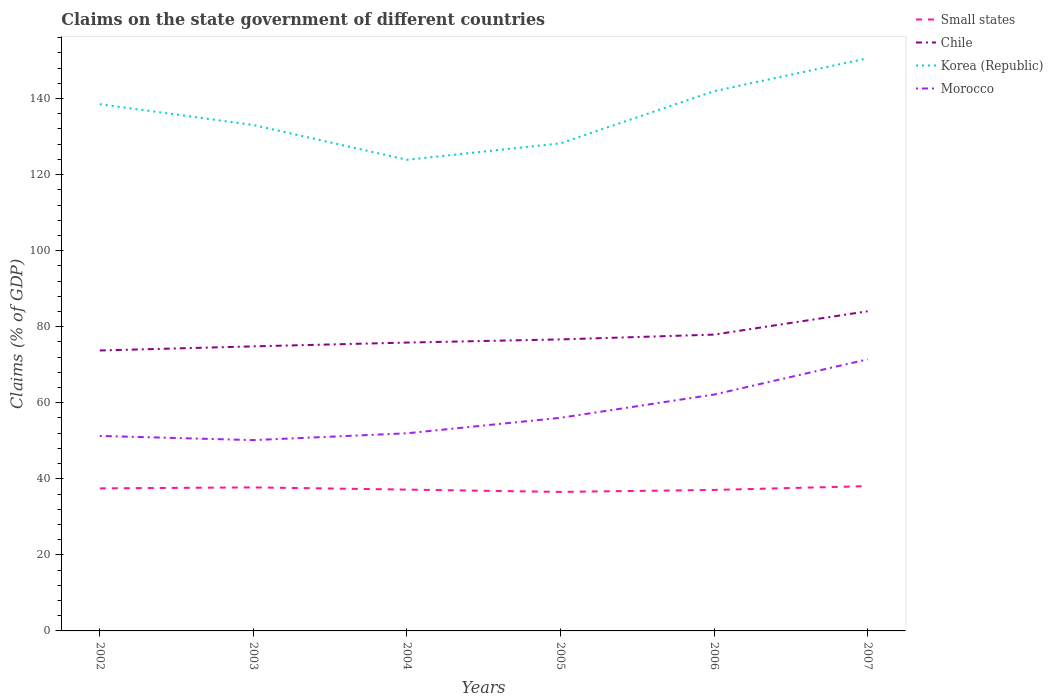How many different coloured lines are there?
Provide a succinct answer. 4. Is the number of lines equal to the number of legend labels?
Keep it short and to the point. Yes. Across all years, what is the maximum percentage of GDP claimed on the state government in Small states?
Provide a succinct answer. 36.56. What is the total percentage of GDP claimed on the state government in Korea (Republic) in the graph?
Your answer should be very brief. -22.38. What is the difference between the highest and the second highest percentage of GDP claimed on the state government in Morocco?
Provide a succinct answer. 21.24. Is the percentage of GDP claimed on the state government in Korea (Republic) strictly greater than the percentage of GDP claimed on the state government in Morocco over the years?
Offer a very short reply. No. How many years are there in the graph?
Your response must be concise. 6. What is the difference between two consecutive major ticks on the Y-axis?
Provide a succinct answer. 20. Does the graph contain grids?
Your answer should be very brief. No. What is the title of the graph?
Provide a succinct answer. Claims on the state government of different countries. Does "Luxembourg" appear as one of the legend labels in the graph?
Make the answer very short. No. What is the label or title of the Y-axis?
Make the answer very short. Claims (% of GDP). What is the Claims (% of GDP) in Small states in 2002?
Your response must be concise. 37.49. What is the Claims (% of GDP) of Chile in 2002?
Provide a short and direct response. 73.75. What is the Claims (% of GDP) in Korea (Republic) in 2002?
Ensure brevity in your answer.  138.52. What is the Claims (% of GDP) in Morocco in 2002?
Ensure brevity in your answer.  51.28. What is the Claims (% of GDP) of Small states in 2003?
Offer a terse response. 37.74. What is the Claims (% of GDP) in Chile in 2003?
Make the answer very short. 74.83. What is the Claims (% of GDP) in Korea (Republic) in 2003?
Your answer should be very brief. 133.05. What is the Claims (% of GDP) in Morocco in 2003?
Your response must be concise. 50.18. What is the Claims (% of GDP) in Small states in 2004?
Offer a terse response. 37.17. What is the Claims (% of GDP) of Chile in 2004?
Provide a short and direct response. 75.83. What is the Claims (% of GDP) in Korea (Republic) in 2004?
Your response must be concise. 123.89. What is the Claims (% of GDP) of Morocco in 2004?
Make the answer very short. 51.97. What is the Claims (% of GDP) of Small states in 2005?
Make the answer very short. 36.56. What is the Claims (% of GDP) in Chile in 2005?
Offer a very short reply. 76.66. What is the Claims (% of GDP) in Korea (Republic) in 2005?
Your response must be concise. 128.22. What is the Claims (% of GDP) in Morocco in 2005?
Make the answer very short. 56.05. What is the Claims (% of GDP) of Small states in 2006?
Provide a succinct answer. 37.08. What is the Claims (% of GDP) of Chile in 2006?
Give a very brief answer. 77.92. What is the Claims (% of GDP) in Korea (Republic) in 2006?
Offer a very short reply. 141.94. What is the Claims (% of GDP) in Morocco in 2006?
Give a very brief answer. 62.16. What is the Claims (% of GDP) of Small states in 2007?
Your response must be concise. 38.07. What is the Claims (% of GDP) of Chile in 2007?
Your response must be concise. 84.06. What is the Claims (% of GDP) in Korea (Republic) in 2007?
Offer a very short reply. 150.6. What is the Claims (% of GDP) of Morocco in 2007?
Offer a terse response. 71.41. Across all years, what is the maximum Claims (% of GDP) of Small states?
Give a very brief answer. 38.07. Across all years, what is the maximum Claims (% of GDP) of Chile?
Provide a short and direct response. 84.06. Across all years, what is the maximum Claims (% of GDP) in Korea (Republic)?
Keep it short and to the point. 150.6. Across all years, what is the maximum Claims (% of GDP) of Morocco?
Provide a short and direct response. 71.41. Across all years, what is the minimum Claims (% of GDP) in Small states?
Your answer should be very brief. 36.56. Across all years, what is the minimum Claims (% of GDP) of Chile?
Provide a succinct answer. 73.75. Across all years, what is the minimum Claims (% of GDP) in Korea (Republic)?
Provide a succinct answer. 123.89. Across all years, what is the minimum Claims (% of GDP) in Morocco?
Provide a succinct answer. 50.18. What is the total Claims (% of GDP) in Small states in the graph?
Your answer should be very brief. 224.1. What is the total Claims (% of GDP) of Chile in the graph?
Keep it short and to the point. 463.06. What is the total Claims (% of GDP) in Korea (Republic) in the graph?
Provide a succinct answer. 816.23. What is the total Claims (% of GDP) of Morocco in the graph?
Provide a short and direct response. 343.05. What is the difference between the Claims (% of GDP) in Small states in 2002 and that in 2003?
Make the answer very short. -0.25. What is the difference between the Claims (% of GDP) of Chile in 2002 and that in 2003?
Provide a short and direct response. -1.08. What is the difference between the Claims (% of GDP) in Korea (Republic) in 2002 and that in 2003?
Offer a very short reply. 5.47. What is the difference between the Claims (% of GDP) of Morocco in 2002 and that in 2003?
Your answer should be compact. 1.1. What is the difference between the Claims (% of GDP) of Small states in 2002 and that in 2004?
Your answer should be very brief. 0.32. What is the difference between the Claims (% of GDP) in Chile in 2002 and that in 2004?
Your answer should be compact. -2.08. What is the difference between the Claims (% of GDP) of Korea (Republic) in 2002 and that in 2004?
Provide a short and direct response. 14.62. What is the difference between the Claims (% of GDP) in Morocco in 2002 and that in 2004?
Your answer should be compact. -0.69. What is the difference between the Claims (% of GDP) in Small states in 2002 and that in 2005?
Give a very brief answer. 0.93. What is the difference between the Claims (% of GDP) in Chile in 2002 and that in 2005?
Your response must be concise. -2.91. What is the difference between the Claims (% of GDP) in Korea (Republic) in 2002 and that in 2005?
Your answer should be compact. 10.3. What is the difference between the Claims (% of GDP) in Morocco in 2002 and that in 2005?
Ensure brevity in your answer.  -4.77. What is the difference between the Claims (% of GDP) of Small states in 2002 and that in 2006?
Your response must be concise. 0.41. What is the difference between the Claims (% of GDP) of Chile in 2002 and that in 2006?
Make the answer very short. -4.17. What is the difference between the Claims (% of GDP) of Korea (Republic) in 2002 and that in 2006?
Your answer should be very brief. -3.42. What is the difference between the Claims (% of GDP) in Morocco in 2002 and that in 2006?
Your answer should be very brief. -10.87. What is the difference between the Claims (% of GDP) of Small states in 2002 and that in 2007?
Make the answer very short. -0.59. What is the difference between the Claims (% of GDP) of Chile in 2002 and that in 2007?
Your answer should be very brief. -10.31. What is the difference between the Claims (% of GDP) of Korea (Republic) in 2002 and that in 2007?
Keep it short and to the point. -12.08. What is the difference between the Claims (% of GDP) in Morocco in 2002 and that in 2007?
Offer a terse response. -20.13. What is the difference between the Claims (% of GDP) in Small states in 2003 and that in 2004?
Give a very brief answer. 0.58. What is the difference between the Claims (% of GDP) of Chile in 2003 and that in 2004?
Offer a very short reply. -1. What is the difference between the Claims (% of GDP) in Korea (Republic) in 2003 and that in 2004?
Your answer should be very brief. 9.15. What is the difference between the Claims (% of GDP) of Morocco in 2003 and that in 2004?
Keep it short and to the point. -1.79. What is the difference between the Claims (% of GDP) of Small states in 2003 and that in 2005?
Your answer should be compact. 1.18. What is the difference between the Claims (% of GDP) of Chile in 2003 and that in 2005?
Keep it short and to the point. -1.83. What is the difference between the Claims (% of GDP) in Korea (Republic) in 2003 and that in 2005?
Make the answer very short. 4.82. What is the difference between the Claims (% of GDP) of Morocco in 2003 and that in 2005?
Offer a terse response. -5.87. What is the difference between the Claims (% of GDP) in Small states in 2003 and that in 2006?
Offer a terse response. 0.66. What is the difference between the Claims (% of GDP) of Chile in 2003 and that in 2006?
Give a very brief answer. -3.09. What is the difference between the Claims (% of GDP) of Korea (Republic) in 2003 and that in 2006?
Your answer should be compact. -8.89. What is the difference between the Claims (% of GDP) in Morocco in 2003 and that in 2006?
Your answer should be very brief. -11.98. What is the difference between the Claims (% of GDP) of Chile in 2003 and that in 2007?
Keep it short and to the point. -9.23. What is the difference between the Claims (% of GDP) of Korea (Republic) in 2003 and that in 2007?
Your response must be concise. -17.55. What is the difference between the Claims (% of GDP) of Morocco in 2003 and that in 2007?
Provide a short and direct response. -21.24. What is the difference between the Claims (% of GDP) in Small states in 2004 and that in 2005?
Give a very brief answer. 0.61. What is the difference between the Claims (% of GDP) in Chile in 2004 and that in 2005?
Your answer should be very brief. -0.83. What is the difference between the Claims (% of GDP) of Korea (Republic) in 2004 and that in 2005?
Your answer should be very brief. -4.33. What is the difference between the Claims (% of GDP) in Morocco in 2004 and that in 2005?
Your answer should be very brief. -4.08. What is the difference between the Claims (% of GDP) of Small states in 2004 and that in 2006?
Make the answer very short. 0.08. What is the difference between the Claims (% of GDP) of Chile in 2004 and that in 2006?
Ensure brevity in your answer.  -2.09. What is the difference between the Claims (% of GDP) of Korea (Republic) in 2004 and that in 2006?
Provide a short and direct response. -18.05. What is the difference between the Claims (% of GDP) in Morocco in 2004 and that in 2006?
Offer a very short reply. -10.19. What is the difference between the Claims (% of GDP) in Small states in 2004 and that in 2007?
Provide a short and direct response. -0.91. What is the difference between the Claims (% of GDP) in Chile in 2004 and that in 2007?
Your answer should be compact. -8.23. What is the difference between the Claims (% of GDP) in Korea (Republic) in 2004 and that in 2007?
Provide a succinct answer. -26.71. What is the difference between the Claims (% of GDP) in Morocco in 2004 and that in 2007?
Your response must be concise. -19.44. What is the difference between the Claims (% of GDP) of Small states in 2005 and that in 2006?
Offer a very short reply. -0.53. What is the difference between the Claims (% of GDP) of Chile in 2005 and that in 2006?
Your response must be concise. -1.26. What is the difference between the Claims (% of GDP) of Korea (Republic) in 2005 and that in 2006?
Give a very brief answer. -13.72. What is the difference between the Claims (% of GDP) in Morocco in 2005 and that in 2006?
Provide a short and direct response. -6.11. What is the difference between the Claims (% of GDP) of Small states in 2005 and that in 2007?
Ensure brevity in your answer.  -1.52. What is the difference between the Claims (% of GDP) in Chile in 2005 and that in 2007?
Provide a succinct answer. -7.4. What is the difference between the Claims (% of GDP) of Korea (Republic) in 2005 and that in 2007?
Your answer should be compact. -22.38. What is the difference between the Claims (% of GDP) of Morocco in 2005 and that in 2007?
Offer a terse response. -15.36. What is the difference between the Claims (% of GDP) of Small states in 2006 and that in 2007?
Provide a succinct answer. -0.99. What is the difference between the Claims (% of GDP) in Chile in 2006 and that in 2007?
Make the answer very short. -6.14. What is the difference between the Claims (% of GDP) in Korea (Republic) in 2006 and that in 2007?
Ensure brevity in your answer.  -8.66. What is the difference between the Claims (% of GDP) in Morocco in 2006 and that in 2007?
Ensure brevity in your answer.  -9.26. What is the difference between the Claims (% of GDP) in Small states in 2002 and the Claims (% of GDP) in Chile in 2003?
Give a very brief answer. -37.35. What is the difference between the Claims (% of GDP) of Small states in 2002 and the Claims (% of GDP) of Korea (Republic) in 2003?
Ensure brevity in your answer.  -95.56. What is the difference between the Claims (% of GDP) in Small states in 2002 and the Claims (% of GDP) in Morocco in 2003?
Provide a succinct answer. -12.69. What is the difference between the Claims (% of GDP) in Chile in 2002 and the Claims (% of GDP) in Korea (Republic) in 2003?
Offer a very short reply. -59.3. What is the difference between the Claims (% of GDP) in Chile in 2002 and the Claims (% of GDP) in Morocco in 2003?
Your answer should be compact. 23.57. What is the difference between the Claims (% of GDP) of Korea (Republic) in 2002 and the Claims (% of GDP) of Morocco in 2003?
Give a very brief answer. 88.34. What is the difference between the Claims (% of GDP) in Small states in 2002 and the Claims (% of GDP) in Chile in 2004?
Your response must be concise. -38.34. What is the difference between the Claims (% of GDP) of Small states in 2002 and the Claims (% of GDP) of Korea (Republic) in 2004?
Offer a very short reply. -86.41. What is the difference between the Claims (% of GDP) of Small states in 2002 and the Claims (% of GDP) of Morocco in 2004?
Your answer should be very brief. -14.48. What is the difference between the Claims (% of GDP) in Chile in 2002 and the Claims (% of GDP) in Korea (Republic) in 2004?
Provide a succinct answer. -50.14. What is the difference between the Claims (% of GDP) in Chile in 2002 and the Claims (% of GDP) in Morocco in 2004?
Keep it short and to the point. 21.78. What is the difference between the Claims (% of GDP) in Korea (Republic) in 2002 and the Claims (% of GDP) in Morocco in 2004?
Your answer should be compact. 86.55. What is the difference between the Claims (% of GDP) of Small states in 2002 and the Claims (% of GDP) of Chile in 2005?
Ensure brevity in your answer.  -39.17. What is the difference between the Claims (% of GDP) of Small states in 2002 and the Claims (% of GDP) of Korea (Republic) in 2005?
Ensure brevity in your answer.  -90.74. What is the difference between the Claims (% of GDP) in Small states in 2002 and the Claims (% of GDP) in Morocco in 2005?
Give a very brief answer. -18.56. What is the difference between the Claims (% of GDP) of Chile in 2002 and the Claims (% of GDP) of Korea (Republic) in 2005?
Your response must be concise. -54.47. What is the difference between the Claims (% of GDP) in Chile in 2002 and the Claims (% of GDP) in Morocco in 2005?
Your answer should be very brief. 17.7. What is the difference between the Claims (% of GDP) in Korea (Republic) in 2002 and the Claims (% of GDP) in Morocco in 2005?
Make the answer very short. 82.47. What is the difference between the Claims (% of GDP) in Small states in 2002 and the Claims (% of GDP) in Chile in 2006?
Your answer should be compact. -40.44. What is the difference between the Claims (% of GDP) in Small states in 2002 and the Claims (% of GDP) in Korea (Republic) in 2006?
Your response must be concise. -104.45. What is the difference between the Claims (% of GDP) in Small states in 2002 and the Claims (% of GDP) in Morocco in 2006?
Give a very brief answer. -24.67. What is the difference between the Claims (% of GDP) of Chile in 2002 and the Claims (% of GDP) of Korea (Republic) in 2006?
Ensure brevity in your answer.  -68.19. What is the difference between the Claims (% of GDP) in Chile in 2002 and the Claims (% of GDP) in Morocco in 2006?
Make the answer very short. 11.59. What is the difference between the Claims (% of GDP) of Korea (Republic) in 2002 and the Claims (% of GDP) of Morocco in 2006?
Provide a short and direct response. 76.36. What is the difference between the Claims (% of GDP) of Small states in 2002 and the Claims (% of GDP) of Chile in 2007?
Provide a short and direct response. -46.57. What is the difference between the Claims (% of GDP) of Small states in 2002 and the Claims (% of GDP) of Korea (Republic) in 2007?
Provide a succinct answer. -113.11. What is the difference between the Claims (% of GDP) in Small states in 2002 and the Claims (% of GDP) in Morocco in 2007?
Give a very brief answer. -33.93. What is the difference between the Claims (% of GDP) in Chile in 2002 and the Claims (% of GDP) in Korea (Republic) in 2007?
Provide a short and direct response. -76.85. What is the difference between the Claims (% of GDP) of Chile in 2002 and the Claims (% of GDP) of Morocco in 2007?
Keep it short and to the point. 2.34. What is the difference between the Claims (% of GDP) of Korea (Republic) in 2002 and the Claims (% of GDP) of Morocco in 2007?
Provide a short and direct response. 67.11. What is the difference between the Claims (% of GDP) in Small states in 2003 and the Claims (% of GDP) in Chile in 2004?
Provide a short and direct response. -38.09. What is the difference between the Claims (% of GDP) of Small states in 2003 and the Claims (% of GDP) of Korea (Republic) in 2004?
Your answer should be very brief. -86.15. What is the difference between the Claims (% of GDP) of Small states in 2003 and the Claims (% of GDP) of Morocco in 2004?
Your answer should be compact. -14.23. What is the difference between the Claims (% of GDP) in Chile in 2003 and the Claims (% of GDP) in Korea (Republic) in 2004?
Your answer should be compact. -49.06. What is the difference between the Claims (% of GDP) in Chile in 2003 and the Claims (% of GDP) in Morocco in 2004?
Make the answer very short. 22.86. What is the difference between the Claims (% of GDP) in Korea (Republic) in 2003 and the Claims (% of GDP) in Morocco in 2004?
Your answer should be very brief. 81.08. What is the difference between the Claims (% of GDP) of Small states in 2003 and the Claims (% of GDP) of Chile in 2005?
Make the answer very short. -38.92. What is the difference between the Claims (% of GDP) of Small states in 2003 and the Claims (% of GDP) of Korea (Republic) in 2005?
Provide a succinct answer. -90.48. What is the difference between the Claims (% of GDP) in Small states in 2003 and the Claims (% of GDP) in Morocco in 2005?
Provide a short and direct response. -18.31. What is the difference between the Claims (% of GDP) in Chile in 2003 and the Claims (% of GDP) in Korea (Republic) in 2005?
Ensure brevity in your answer.  -53.39. What is the difference between the Claims (% of GDP) of Chile in 2003 and the Claims (% of GDP) of Morocco in 2005?
Keep it short and to the point. 18.78. What is the difference between the Claims (% of GDP) in Korea (Republic) in 2003 and the Claims (% of GDP) in Morocco in 2005?
Offer a very short reply. 77. What is the difference between the Claims (% of GDP) in Small states in 2003 and the Claims (% of GDP) in Chile in 2006?
Your answer should be compact. -40.18. What is the difference between the Claims (% of GDP) in Small states in 2003 and the Claims (% of GDP) in Korea (Republic) in 2006?
Your answer should be compact. -104.2. What is the difference between the Claims (% of GDP) of Small states in 2003 and the Claims (% of GDP) of Morocco in 2006?
Provide a succinct answer. -24.42. What is the difference between the Claims (% of GDP) of Chile in 2003 and the Claims (% of GDP) of Korea (Republic) in 2006?
Provide a succinct answer. -67.11. What is the difference between the Claims (% of GDP) in Chile in 2003 and the Claims (% of GDP) in Morocco in 2006?
Your response must be concise. 12.68. What is the difference between the Claims (% of GDP) in Korea (Republic) in 2003 and the Claims (% of GDP) in Morocco in 2006?
Make the answer very short. 70.89. What is the difference between the Claims (% of GDP) of Small states in 2003 and the Claims (% of GDP) of Chile in 2007?
Your response must be concise. -46.32. What is the difference between the Claims (% of GDP) in Small states in 2003 and the Claims (% of GDP) in Korea (Republic) in 2007?
Your answer should be compact. -112.86. What is the difference between the Claims (% of GDP) of Small states in 2003 and the Claims (% of GDP) of Morocco in 2007?
Your response must be concise. -33.67. What is the difference between the Claims (% of GDP) of Chile in 2003 and the Claims (% of GDP) of Korea (Republic) in 2007?
Keep it short and to the point. -75.77. What is the difference between the Claims (% of GDP) in Chile in 2003 and the Claims (% of GDP) in Morocco in 2007?
Offer a very short reply. 3.42. What is the difference between the Claims (% of GDP) of Korea (Republic) in 2003 and the Claims (% of GDP) of Morocco in 2007?
Provide a succinct answer. 61.64. What is the difference between the Claims (% of GDP) in Small states in 2004 and the Claims (% of GDP) in Chile in 2005?
Ensure brevity in your answer.  -39.5. What is the difference between the Claims (% of GDP) of Small states in 2004 and the Claims (% of GDP) of Korea (Republic) in 2005?
Provide a succinct answer. -91.06. What is the difference between the Claims (% of GDP) in Small states in 2004 and the Claims (% of GDP) in Morocco in 2005?
Offer a terse response. -18.88. What is the difference between the Claims (% of GDP) in Chile in 2004 and the Claims (% of GDP) in Korea (Republic) in 2005?
Make the answer very short. -52.39. What is the difference between the Claims (% of GDP) in Chile in 2004 and the Claims (% of GDP) in Morocco in 2005?
Give a very brief answer. 19.78. What is the difference between the Claims (% of GDP) of Korea (Republic) in 2004 and the Claims (% of GDP) of Morocco in 2005?
Provide a short and direct response. 67.85. What is the difference between the Claims (% of GDP) in Small states in 2004 and the Claims (% of GDP) in Chile in 2006?
Keep it short and to the point. -40.76. What is the difference between the Claims (% of GDP) in Small states in 2004 and the Claims (% of GDP) in Korea (Republic) in 2006?
Give a very brief answer. -104.78. What is the difference between the Claims (% of GDP) in Small states in 2004 and the Claims (% of GDP) in Morocco in 2006?
Provide a short and direct response. -24.99. What is the difference between the Claims (% of GDP) in Chile in 2004 and the Claims (% of GDP) in Korea (Republic) in 2006?
Offer a terse response. -66.11. What is the difference between the Claims (% of GDP) in Chile in 2004 and the Claims (% of GDP) in Morocco in 2006?
Give a very brief answer. 13.68. What is the difference between the Claims (% of GDP) in Korea (Republic) in 2004 and the Claims (% of GDP) in Morocco in 2006?
Provide a succinct answer. 61.74. What is the difference between the Claims (% of GDP) of Small states in 2004 and the Claims (% of GDP) of Chile in 2007?
Offer a very short reply. -46.9. What is the difference between the Claims (% of GDP) in Small states in 2004 and the Claims (% of GDP) in Korea (Republic) in 2007?
Give a very brief answer. -113.43. What is the difference between the Claims (% of GDP) of Small states in 2004 and the Claims (% of GDP) of Morocco in 2007?
Provide a succinct answer. -34.25. What is the difference between the Claims (% of GDP) of Chile in 2004 and the Claims (% of GDP) of Korea (Republic) in 2007?
Make the answer very short. -74.77. What is the difference between the Claims (% of GDP) in Chile in 2004 and the Claims (% of GDP) in Morocco in 2007?
Ensure brevity in your answer.  4.42. What is the difference between the Claims (% of GDP) of Korea (Republic) in 2004 and the Claims (% of GDP) of Morocco in 2007?
Provide a short and direct response. 52.48. What is the difference between the Claims (% of GDP) in Small states in 2005 and the Claims (% of GDP) in Chile in 2006?
Offer a very short reply. -41.37. What is the difference between the Claims (% of GDP) in Small states in 2005 and the Claims (% of GDP) in Korea (Republic) in 2006?
Make the answer very short. -105.38. What is the difference between the Claims (% of GDP) in Small states in 2005 and the Claims (% of GDP) in Morocco in 2006?
Offer a very short reply. -25.6. What is the difference between the Claims (% of GDP) in Chile in 2005 and the Claims (% of GDP) in Korea (Republic) in 2006?
Offer a terse response. -65.28. What is the difference between the Claims (% of GDP) in Chile in 2005 and the Claims (% of GDP) in Morocco in 2006?
Ensure brevity in your answer.  14.51. What is the difference between the Claims (% of GDP) in Korea (Republic) in 2005 and the Claims (% of GDP) in Morocco in 2006?
Ensure brevity in your answer.  66.07. What is the difference between the Claims (% of GDP) in Small states in 2005 and the Claims (% of GDP) in Chile in 2007?
Make the answer very short. -47.5. What is the difference between the Claims (% of GDP) of Small states in 2005 and the Claims (% of GDP) of Korea (Republic) in 2007?
Offer a terse response. -114.04. What is the difference between the Claims (% of GDP) in Small states in 2005 and the Claims (% of GDP) in Morocco in 2007?
Your response must be concise. -34.86. What is the difference between the Claims (% of GDP) in Chile in 2005 and the Claims (% of GDP) in Korea (Republic) in 2007?
Give a very brief answer. -73.94. What is the difference between the Claims (% of GDP) in Chile in 2005 and the Claims (% of GDP) in Morocco in 2007?
Offer a very short reply. 5.25. What is the difference between the Claims (% of GDP) of Korea (Republic) in 2005 and the Claims (% of GDP) of Morocco in 2007?
Give a very brief answer. 56.81. What is the difference between the Claims (% of GDP) of Small states in 2006 and the Claims (% of GDP) of Chile in 2007?
Offer a very short reply. -46.98. What is the difference between the Claims (% of GDP) in Small states in 2006 and the Claims (% of GDP) in Korea (Republic) in 2007?
Give a very brief answer. -113.52. What is the difference between the Claims (% of GDP) of Small states in 2006 and the Claims (% of GDP) of Morocco in 2007?
Your answer should be very brief. -34.33. What is the difference between the Claims (% of GDP) in Chile in 2006 and the Claims (% of GDP) in Korea (Republic) in 2007?
Provide a succinct answer. -72.68. What is the difference between the Claims (% of GDP) in Chile in 2006 and the Claims (% of GDP) in Morocco in 2007?
Keep it short and to the point. 6.51. What is the difference between the Claims (% of GDP) in Korea (Republic) in 2006 and the Claims (% of GDP) in Morocco in 2007?
Your response must be concise. 70.53. What is the average Claims (% of GDP) in Small states per year?
Your response must be concise. 37.35. What is the average Claims (% of GDP) in Chile per year?
Your answer should be compact. 77.18. What is the average Claims (% of GDP) of Korea (Republic) per year?
Offer a very short reply. 136.04. What is the average Claims (% of GDP) in Morocco per year?
Offer a very short reply. 57.17. In the year 2002, what is the difference between the Claims (% of GDP) of Small states and Claims (% of GDP) of Chile?
Keep it short and to the point. -36.26. In the year 2002, what is the difference between the Claims (% of GDP) of Small states and Claims (% of GDP) of Korea (Republic)?
Offer a terse response. -101.03. In the year 2002, what is the difference between the Claims (% of GDP) in Small states and Claims (% of GDP) in Morocco?
Keep it short and to the point. -13.79. In the year 2002, what is the difference between the Claims (% of GDP) in Chile and Claims (% of GDP) in Korea (Republic)?
Offer a very short reply. -64.77. In the year 2002, what is the difference between the Claims (% of GDP) of Chile and Claims (% of GDP) of Morocco?
Provide a short and direct response. 22.47. In the year 2002, what is the difference between the Claims (% of GDP) of Korea (Republic) and Claims (% of GDP) of Morocco?
Your answer should be compact. 87.24. In the year 2003, what is the difference between the Claims (% of GDP) of Small states and Claims (% of GDP) of Chile?
Offer a terse response. -37.09. In the year 2003, what is the difference between the Claims (% of GDP) in Small states and Claims (% of GDP) in Korea (Republic)?
Ensure brevity in your answer.  -95.31. In the year 2003, what is the difference between the Claims (% of GDP) of Small states and Claims (% of GDP) of Morocco?
Provide a succinct answer. -12.44. In the year 2003, what is the difference between the Claims (% of GDP) in Chile and Claims (% of GDP) in Korea (Republic)?
Make the answer very short. -58.22. In the year 2003, what is the difference between the Claims (% of GDP) of Chile and Claims (% of GDP) of Morocco?
Give a very brief answer. 24.66. In the year 2003, what is the difference between the Claims (% of GDP) in Korea (Republic) and Claims (% of GDP) in Morocco?
Provide a succinct answer. 82.87. In the year 2004, what is the difference between the Claims (% of GDP) in Small states and Claims (% of GDP) in Chile?
Your answer should be compact. -38.67. In the year 2004, what is the difference between the Claims (% of GDP) in Small states and Claims (% of GDP) in Korea (Republic)?
Offer a very short reply. -86.73. In the year 2004, what is the difference between the Claims (% of GDP) in Small states and Claims (% of GDP) in Morocco?
Give a very brief answer. -14.81. In the year 2004, what is the difference between the Claims (% of GDP) of Chile and Claims (% of GDP) of Korea (Republic)?
Provide a short and direct response. -48.06. In the year 2004, what is the difference between the Claims (% of GDP) of Chile and Claims (% of GDP) of Morocco?
Keep it short and to the point. 23.86. In the year 2004, what is the difference between the Claims (% of GDP) of Korea (Republic) and Claims (% of GDP) of Morocco?
Provide a short and direct response. 71.92. In the year 2005, what is the difference between the Claims (% of GDP) of Small states and Claims (% of GDP) of Chile?
Offer a terse response. -40.11. In the year 2005, what is the difference between the Claims (% of GDP) of Small states and Claims (% of GDP) of Korea (Republic)?
Ensure brevity in your answer.  -91.67. In the year 2005, what is the difference between the Claims (% of GDP) of Small states and Claims (% of GDP) of Morocco?
Provide a succinct answer. -19.49. In the year 2005, what is the difference between the Claims (% of GDP) of Chile and Claims (% of GDP) of Korea (Republic)?
Keep it short and to the point. -51.56. In the year 2005, what is the difference between the Claims (% of GDP) in Chile and Claims (% of GDP) in Morocco?
Your answer should be compact. 20.61. In the year 2005, what is the difference between the Claims (% of GDP) in Korea (Republic) and Claims (% of GDP) in Morocco?
Make the answer very short. 72.18. In the year 2006, what is the difference between the Claims (% of GDP) in Small states and Claims (% of GDP) in Chile?
Your answer should be very brief. -40.84. In the year 2006, what is the difference between the Claims (% of GDP) of Small states and Claims (% of GDP) of Korea (Republic)?
Give a very brief answer. -104.86. In the year 2006, what is the difference between the Claims (% of GDP) of Small states and Claims (% of GDP) of Morocco?
Offer a very short reply. -25.07. In the year 2006, what is the difference between the Claims (% of GDP) in Chile and Claims (% of GDP) in Korea (Republic)?
Provide a short and direct response. -64.02. In the year 2006, what is the difference between the Claims (% of GDP) in Chile and Claims (% of GDP) in Morocco?
Your answer should be compact. 15.77. In the year 2006, what is the difference between the Claims (% of GDP) of Korea (Republic) and Claims (% of GDP) of Morocco?
Your answer should be compact. 79.78. In the year 2007, what is the difference between the Claims (% of GDP) of Small states and Claims (% of GDP) of Chile?
Offer a very short reply. -45.99. In the year 2007, what is the difference between the Claims (% of GDP) of Small states and Claims (% of GDP) of Korea (Republic)?
Your answer should be compact. -112.53. In the year 2007, what is the difference between the Claims (% of GDP) in Small states and Claims (% of GDP) in Morocco?
Offer a very short reply. -33.34. In the year 2007, what is the difference between the Claims (% of GDP) of Chile and Claims (% of GDP) of Korea (Republic)?
Offer a very short reply. -66.54. In the year 2007, what is the difference between the Claims (% of GDP) of Chile and Claims (% of GDP) of Morocco?
Make the answer very short. 12.65. In the year 2007, what is the difference between the Claims (% of GDP) in Korea (Republic) and Claims (% of GDP) in Morocco?
Make the answer very short. 79.19. What is the ratio of the Claims (% of GDP) in Chile in 2002 to that in 2003?
Your answer should be very brief. 0.99. What is the ratio of the Claims (% of GDP) of Korea (Republic) in 2002 to that in 2003?
Your answer should be compact. 1.04. What is the ratio of the Claims (% of GDP) in Morocco in 2002 to that in 2003?
Your answer should be compact. 1.02. What is the ratio of the Claims (% of GDP) in Small states in 2002 to that in 2004?
Provide a succinct answer. 1.01. What is the ratio of the Claims (% of GDP) of Chile in 2002 to that in 2004?
Give a very brief answer. 0.97. What is the ratio of the Claims (% of GDP) of Korea (Republic) in 2002 to that in 2004?
Provide a succinct answer. 1.12. What is the ratio of the Claims (% of GDP) of Morocco in 2002 to that in 2004?
Offer a terse response. 0.99. What is the ratio of the Claims (% of GDP) of Small states in 2002 to that in 2005?
Offer a terse response. 1.03. What is the ratio of the Claims (% of GDP) of Chile in 2002 to that in 2005?
Offer a very short reply. 0.96. What is the ratio of the Claims (% of GDP) in Korea (Republic) in 2002 to that in 2005?
Offer a terse response. 1.08. What is the ratio of the Claims (% of GDP) in Morocco in 2002 to that in 2005?
Keep it short and to the point. 0.91. What is the ratio of the Claims (% of GDP) in Small states in 2002 to that in 2006?
Provide a short and direct response. 1.01. What is the ratio of the Claims (% of GDP) in Chile in 2002 to that in 2006?
Keep it short and to the point. 0.95. What is the ratio of the Claims (% of GDP) in Korea (Republic) in 2002 to that in 2006?
Your answer should be compact. 0.98. What is the ratio of the Claims (% of GDP) in Morocco in 2002 to that in 2006?
Provide a succinct answer. 0.83. What is the ratio of the Claims (% of GDP) of Small states in 2002 to that in 2007?
Make the answer very short. 0.98. What is the ratio of the Claims (% of GDP) in Chile in 2002 to that in 2007?
Make the answer very short. 0.88. What is the ratio of the Claims (% of GDP) in Korea (Republic) in 2002 to that in 2007?
Provide a succinct answer. 0.92. What is the ratio of the Claims (% of GDP) of Morocco in 2002 to that in 2007?
Your answer should be very brief. 0.72. What is the ratio of the Claims (% of GDP) in Small states in 2003 to that in 2004?
Offer a very short reply. 1.02. What is the ratio of the Claims (% of GDP) in Korea (Republic) in 2003 to that in 2004?
Your response must be concise. 1.07. What is the ratio of the Claims (% of GDP) of Morocco in 2003 to that in 2004?
Your answer should be very brief. 0.97. What is the ratio of the Claims (% of GDP) of Small states in 2003 to that in 2005?
Provide a succinct answer. 1.03. What is the ratio of the Claims (% of GDP) in Chile in 2003 to that in 2005?
Offer a very short reply. 0.98. What is the ratio of the Claims (% of GDP) in Korea (Republic) in 2003 to that in 2005?
Keep it short and to the point. 1.04. What is the ratio of the Claims (% of GDP) of Morocco in 2003 to that in 2005?
Ensure brevity in your answer.  0.9. What is the ratio of the Claims (% of GDP) of Small states in 2003 to that in 2006?
Offer a very short reply. 1.02. What is the ratio of the Claims (% of GDP) of Chile in 2003 to that in 2006?
Your response must be concise. 0.96. What is the ratio of the Claims (% of GDP) in Korea (Republic) in 2003 to that in 2006?
Your response must be concise. 0.94. What is the ratio of the Claims (% of GDP) of Morocco in 2003 to that in 2006?
Provide a succinct answer. 0.81. What is the ratio of the Claims (% of GDP) in Chile in 2003 to that in 2007?
Your answer should be very brief. 0.89. What is the ratio of the Claims (% of GDP) in Korea (Republic) in 2003 to that in 2007?
Make the answer very short. 0.88. What is the ratio of the Claims (% of GDP) of Morocco in 2003 to that in 2007?
Your response must be concise. 0.7. What is the ratio of the Claims (% of GDP) in Small states in 2004 to that in 2005?
Provide a short and direct response. 1.02. What is the ratio of the Claims (% of GDP) in Korea (Republic) in 2004 to that in 2005?
Keep it short and to the point. 0.97. What is the ratio of the Claims (% of GDP) in Morocco in 2004 to that in 2005?
Keep it short and to the point. 0.93. What is the ratio of the Claims (% of GDP) in Small states in 2004 to that in 2006?
Your answer should be very brief. 1. What is the ratio of the Claims (% of GDP) of Chile in 2004 to that in 2006?
Ensure brevity in your answer.  0.97. What is the ratio of the Claims (% of GDP) in Korea (Republic) in 2004 to that in 2006?
Your response must be concise. 0.87. What is the ratio of the Claims (% of GDP) in Morocco in 2004 to that in 2006?
Keep it short and to the point. 0.84. What is the ratio of the Claims (% of GDP) of Small states in 2004 to that in 2007?
Ensure brevity in your answer.  0.98. What is the ratio of the Claims (% of GDP) of Chile in 2004 to that in 2007?
Offer a very short reply. 0.9. What is the ratio of the Claims (% of GDP) in Korea (Republic) in 2004 to that in 2007?
Make the answer very short. 0.82. What is the ratio of the Claims (% of GDP) of Morocco in 2004 to that in 2007?
Provide a succinct answer. 0.73. What is the ratio of the Claims (% of GDP) of Small states in 2005 to that in 2006?
Provide a succinct answer. 0.99. What is the ratio of the Claims (% of GDP) in Chile in 2005 to that in 2006?
Provide a short and direct response. 0.98. What is the ratio of the Claims (% of GDP) of Korea (Republic) in 2005 to that in 2006?
Provide a succinct answer. 0.9. What is the ratio of the Claims (% of GDP) of Morocco in 2005 to that in 2006?
Offer a terse response. 0.9. What is the ratio of the Claims (% of GDP) in Small states in 2005 to that in 2007?
Provide a short and direct response. 0.96. What is the ratio of the Claims (% of GDP) of Chile in 2005 to that in 2007?
Give a very brief answer. 0.91. What is the ratio of the Claims (% of GDP) in Korea (Republic) in 2005 to that in 2007?
Offer a terse response. 0.85. What is the ratio of the Claims (% of GDP) of Morocco in 2005 to that in 2007?
Keep it short and to the point. 0.78. What is the ratio of the Claims (% of GDP) in Small states in 2006 to that in 2007?
Provide a succinct answer. 0.97. What is the ratio of the Claims (% of GDP) of Chile in 2006 to that in 2007?
Provide a short and direct response. 0.93. What is the ratio of the Claims (% of GDP) in Korea (Republic) in 2006 to that in 2007?
Your answer should be very brief. 0.94. What is the ratio of the Claims (% of GDP) in Morocco in 2006 to that in 2007?
Your response must be concise. 0.87. What is the difference between the highest and the second highest Claims (% of GDP) in Chile?
Your answer should be compact. 6.14. What is the difference between the highest and the second highest Claims (% of GDP) of Korea (Republic)?
Keep it short and to the point. 8.66. What is the difference between the highest and the second highest Claims (% of GDP) in Morocco?
Offer a terse response. 9.26. What is the difference between the highest and the lowest Claims (% of GDP) in Small states?
Provide a succinct answer. 1.52. What is the difference between the highest and the lowest Claims (% of GDP) of Chile?
Your response must be concise. 10.31. What is the difference between the highest and the lowest Claims (% of GDP) in Korea (Republic)?
Keep it short and to the point. 26.71. What is the difference between the highest and the lowest Claims (% of GDP) in Morocco?
Make the answer very short. 21.24. 